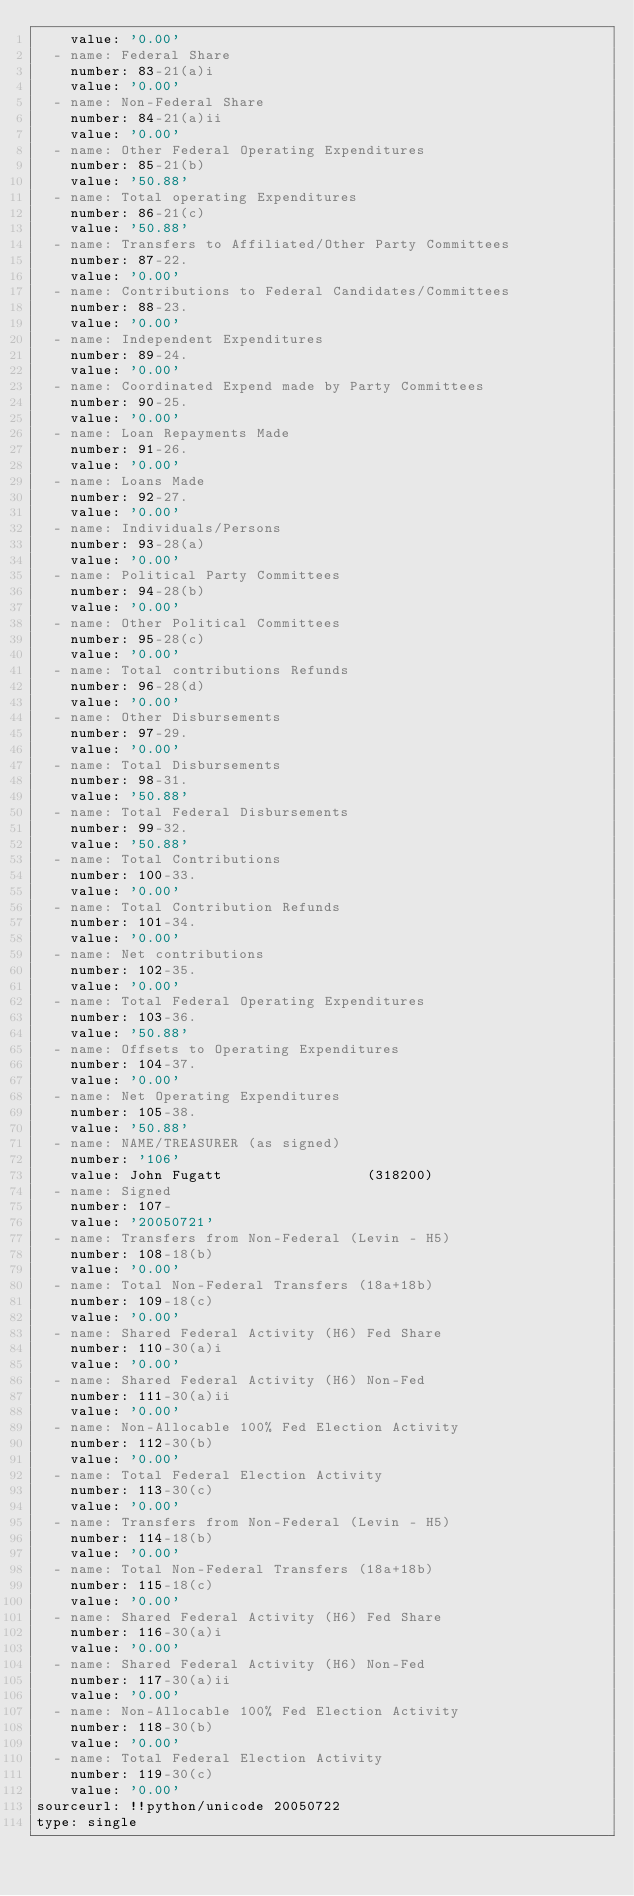Convert code to text. <code><loc_0><loc_0><loc_500><loc_500><_YAML_>    value: '0.00'
  - name: Federal Share
    number: 83-21(a)i
    value: '0.00'
  - name: Non-Federal Share
    number: 84-21(a)ii
    value: '0.00'
  - name: Other Federal Operating Expenditures
    number: 85-21(b)
    value: '50.88'
  - name: Total operating Expenditures
    number: 86-21(c)
    value: '50.88'
  - name: Transfers to Affiliated/Other Party Committees
    number: 87-22.
    value: '0.00'
  - name: Contributions to Federal Candidates/Committees
    number: 88-23.
    value: '0.00'
  - name: Independent Expenditures
    number: 89-24.
    value: '0.00'
  - name: Coordinated Expend made by Party Committees
    number: 90-25.
    value: '0.00'
  - name: Loan Repayments Made
    number: 91-26.
    value: '0.00'
  - name: Loans Made
    number: 92-27.
    value: '0.00'
  - name: Individuals/Persons
    number: 93-28(a)
    value: '0.00'
  - name: Political Party Committees
    number: 94-28(b)
    value: '0.00'
  - name: Other Political Committees
    number: 95-28(c)
    value: '0.00'
  - name: Total contributions Refunds
    number: 96-28(d)
    value: '0.00'
  - name: Other Disbursements
    number: 97-29.
    value: '0.00'
  - name: Total Disbursements
    number: 98-31.
    value: '50.88'
  - name: Total Federal Disbursements
    number: 99-32.
    value: '50.88'
  - name: Total Contributions
    number: 100-33.
    value: '0.00'
  - name: Total Contribution Refunds
    number: 101-34.
    value: '0.00'
  - name: Net contributions
    number: 102-35.
    value: '0.00'
  - name: Total Federal Operating Expenditures
    number: 103-36.
    value: '50.88'
  - name: Offsets to Operating Expenditures
    number: 104-37.
    value: '0.00'
  - name: Net Operating Expenditures
    number: 105-38.
    value: '50.88'
  - name: NAME/TREASURER (as signed)
    number: '106'
    value: John Fugatt                 (318200)
  - name: Signed
    number: 107-
    value: '20050721'
  - name: Transfers from Non-Federal (Levin - H5)
    number: 108-18(b)
    value: '0.00'
  - name: Total Non-Federal Transfers (18a+18b)
    number: 109-18(c)
    value: '0.00'
  - name: Shared Federal Activity (H6) Fed Share
    number: 110-30(a)i
    value: '0.00'
  - name: Shared Federal Activity (H6) Non-Fed
    number: 111-30(a)ii
    value: '0.00'
  - name: Non-Allocable 100% Fed Election Activity
    number: 112-30(b)
    value: '0.00'
  - name: Total Federal Election Activity
    number: 113-30(c)
    value: '0.00'
  - name: Transfers from Non-Federal (Levin - H5)
    number: 114-18(b)
    value: '0.00'
  - name: Total Non-Federal Transfers (18a+18b)
    number: 115-18(c)
    value: '0.00'
  - name: Shared Federal Activity (H6) Fed Share
    number: 116-30(a)i
    value: '0.00'
  - name: Shared Federal Activity (H6) Non-Fed
    number: 117-30(a)ii
    value: '0.00'
  - name: Non-Allocable 100% Fed Election Activity
    number: 118-30(b)
    value: '0.00'
  - name: Total Federal Election Activity
    number: 119-30(c)
    value: '0.00'
sourceurl: !!python/unicode 20050722
type: single
</code> 